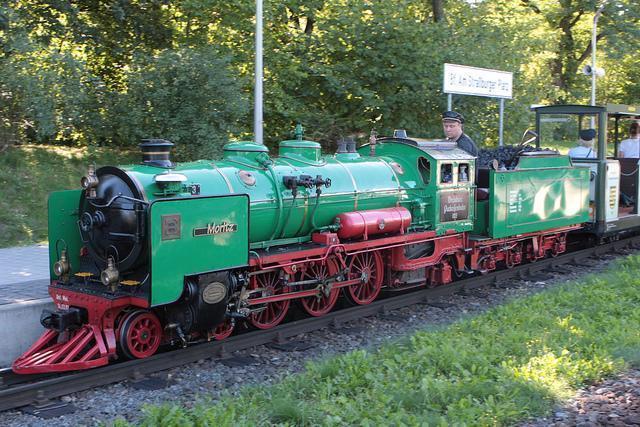What is the man doing at the front of the train car?
Indicate the correct response by choosing from the four available options to answer the question.
Options: Painting, stopping, chaining, driving. Driving. 